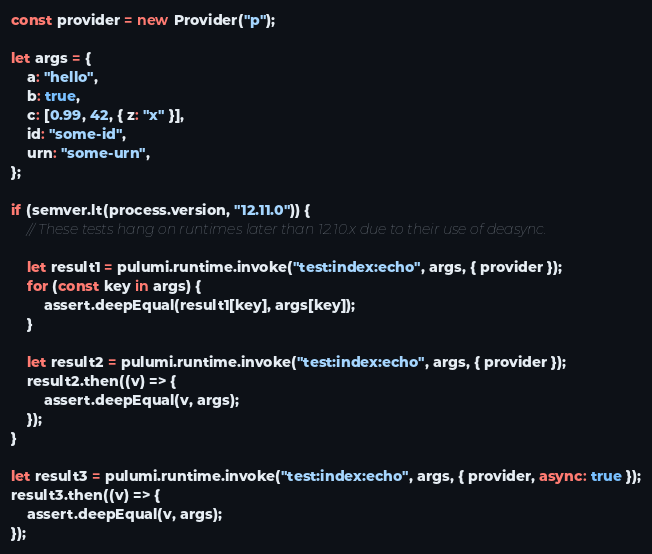<code> <loc_0><loc_0><loc_500><loc_500><_JavaScript_>const provider = new Provider("p");

let args = {
    a: "hello",
    b: true,
    c: [0.99, 42, { z: "x" }],
    id: "some-id",
    urn: "some-urn",
};

if (semver.lt(process.version, "12.11.0")) {
	// These tests hang on runtimes later than 12.10.x due to their use of deasync.

	let result1 = pulumi.runtime.invoke("test:index:echo", args, { provider });
	for (const key in args) {
		assert.deepEqual(result1[key], args[key]);
	}

	let result2 = pulumi.runtime.invoke("test:index:echo", args, { provider });
	result2.then((v) => {
		assert.deepEqual(v, args);
	});
}

let result3 = pulumi.runtime.invoke("test:index:echo", args, { provider, async: true });
result3.then((v) => {
    assert.deepEqual(v, args);
});
</code> 